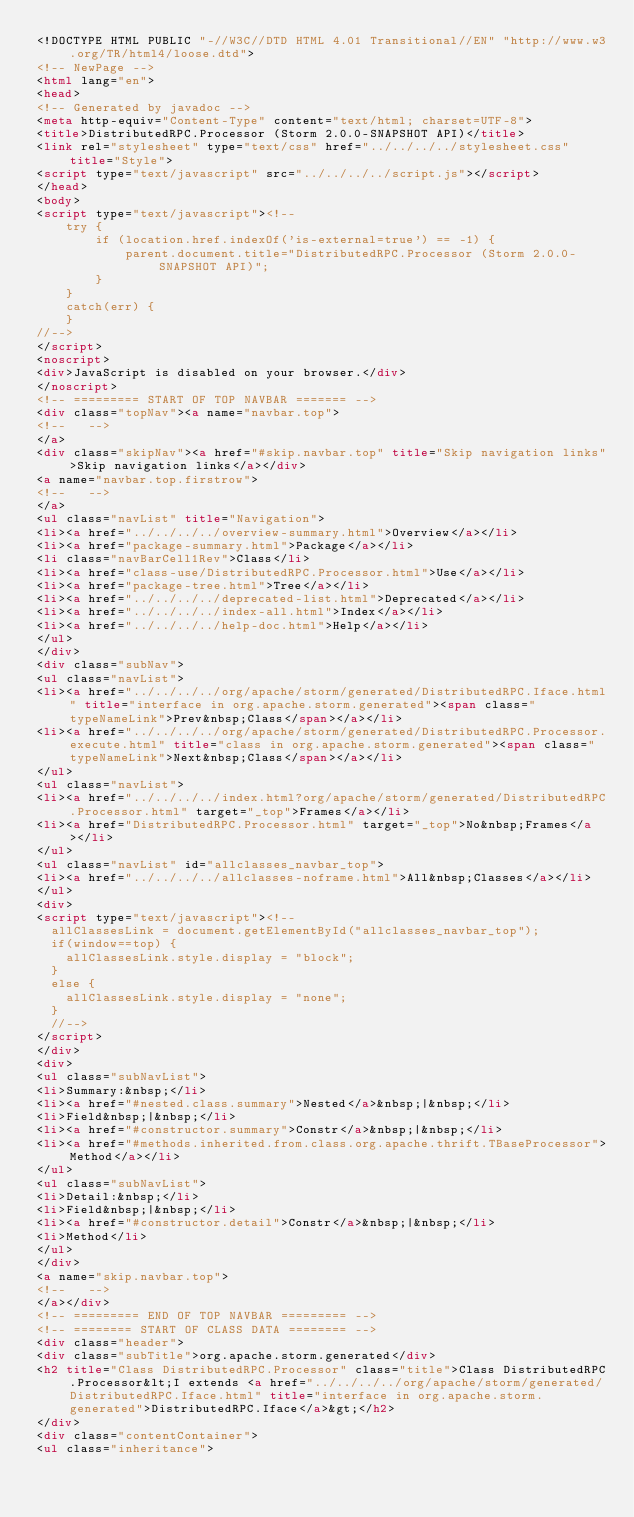Convert code to text. <code><loc_0><loc_0><loc_500><loc_500><_HTML_><!DOCTYPE HTML PUBLIC "-//W3C//DTD HTML 4.01 Transitional//EN" "http://www.w3.org/TR/html4/loose.dtd">
<!-- NewPage -->
<html lang="en">
<head>
<!-- Generated by javadoc -->
<meta http-equiv="Content-Type" content="text/html; charset=UTF-8">
<title>DistributedRPC.Processor (Storm 2.0.0-SNAPSHOT API)</title>
<link rel="stylesheet" type="text/css" href="../../../../stylesheet.css" title="Style">
<script type="text/javascript" src="../../../../script.js"></script>
</head>
<body>
<script type="text/javascript"><!--
    try {
        if (location.href.indexOf('is-external=true') == -1) {
            parent.document.title="DistributedRPC.Processor (Storm 2.0.0-SNAPSHOT API)";
        }
    }
    catch(err) {
    }
//-->
</script>
<noscript>
<div>JavaScript is disabled on your browser.</div>
</noscript>
<!-- ========= START OF TOP NAVBAR ======= -->
<div class="topNav"><a name="navbar.top">
<!--   -->
</a>
<div class="skipNav"><a href="#skip.navbar.top" title="Skip navigation links">Skip navigation links</a></div>
<a name="navbar.top.firstrow">
<!--   -->
</a>
<ul class="navList" title="Navigation">
<li><a href="../../../../overview-summary.html">Overview</a></li>
<li><a href="package-summary.html">Package</a></li>
<li class="navBarCell1Rev">Class</li>
<li><a href="class-use/DistributedRPC.Processor.html">Use</a></li>
<li><a href="package-tree.html">Tree</a></li>
<li><a href="../../../../deprecated-list.html">Deprecated</a></li>
<li><a href="../../../../index-all.html">Index</a></li>
<li><a href="../../../../help-doc.html">Help</a></li>
</ul>
</div>
<div class="subNav">
<ul class="navList">
<li><a href="../../../../org/apache/storm/generated/DistributedRPC.Iface.html" title="interface in org.apache.storm.generated"><span class="typeNameLink">Prev&nbsp;Class</span></a></li>
<li><a href="../../../../org/apache/storm/generated/DistributedRPC.Processor.execute.html" title="class in org.apache.storm.generated"><span class="typeNameLink">Next&nbsp;Class</span></a></li>
</ul>
<ul class="navList">
<li><a href="../../../../index.html?org/apache/storm/generated/DistributedRPC.Processor.html" target="_top">Frames</a></li>
<li><a href="DistributedRPC.Processor.html" target="_top">No&nbsp;Frames</a></li>
</ul>
<ul class="navList" id="allclasses_navbar_top">
<li><a href="../../../../allclasses-noframe.html">All&nbsp;Classes</a></li>
</ul>
<div>
<script type="text/javascript"><!--
  allClassesLink = document.getElementById("allclasses_navbar_top");
  if(window==top) {
    allClassesLink.style.display = "block";
  }
  else {
    allClassesLink.style.display = "none";
  }
  //-->
</script>
</div>
<div>
<ul class="subNavList">
<li>Summary:&nbsp;</li>
<li><a href="#nested.class.summary">Nested</a>&nbsp;|&nbsp;</li>
<li>Field&nbsp;|&nbsp;</li>
<li><a href="#constructor.summary">Constr</a>&nbsp;|&nbsp;</li>
<li><a href="#methods.inherited.from.class.org.apache.thrift.TBaseProcessor">Method</a></li>
</ul>
<ul class="subNavList">
<li>Detail:&nbsp;</li>
<li>Field&nbsp;|&nbsp;</li>
<li><a href="#constructor.detail">Constr</a>&nbsp;|&nbsp;</li>
<li>Method</li>
</ul>
</div>
<a name="skip.navbar.top">
<!--   -->
</a></div>
<!-- ========= END OF TOP NAVBAR ========= -->
<!-- ======== START OF CLASS DATA ======== -->
<div class="header">
<div class="subTitle">org.apache.storm.generated</div>
<h2 title="Class DistributedRPC.Processor" class="title">Class DistributedRPC.Processor&lt;I extends <a href="../../../../org/apache/storm/generated/DistributedRPC.Iface.html" title="interface in org.apache.storm.generated">DistributedRPC.Iface</a>&gt;</h2>
</div>
<div class="contentContainer">
<ul class="inheritance"></code> 